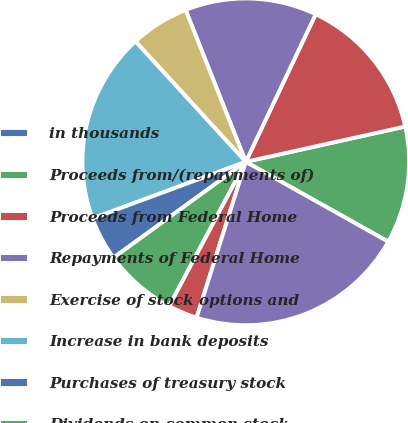Convert chart. <chart><loc_0><loc_0><loc_500><loc_500><pie_chart><fcel>in thousands<fcel>Proceeds from/(repayments of)<fcel>Proceeds from Federal Home<fcel>Repayments of Federal Home<fcel>Exercise of stock options and<fcel>Increase in bank deposits<fcel>Purchases of treasury stock<fcel>Dividends on common stock<fcel>Distributions to<fcel>Net cash provided by financing<nl><fcel>0.01%<fcel>11.59%<fcel>14.49%<fcel>13.04%<fcel>5.8%<fcel>18.83%<fcel>4.35%<fcel>7.25%<fcel>2.9%<fcel>21.73%<nl></chart> 